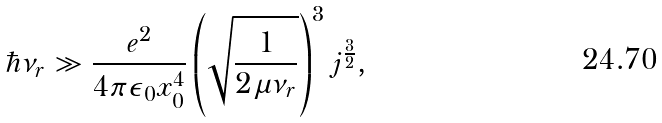<formula> <loc_0><loc_0><loc_500><loc_500>\hbar { \nu } _ { r } \gg \frac { e ^ { 2 } } { 4 \pi \epsilon _ { 0 } x _ { 0 } ^ { 4 } } \left ( \sqrt { \frac { 1 } { 2 \mu \nu _ { r } } } \right ) ^ { 3 } j ^ { \frac { 3 } { 2 } } ,</formula> 